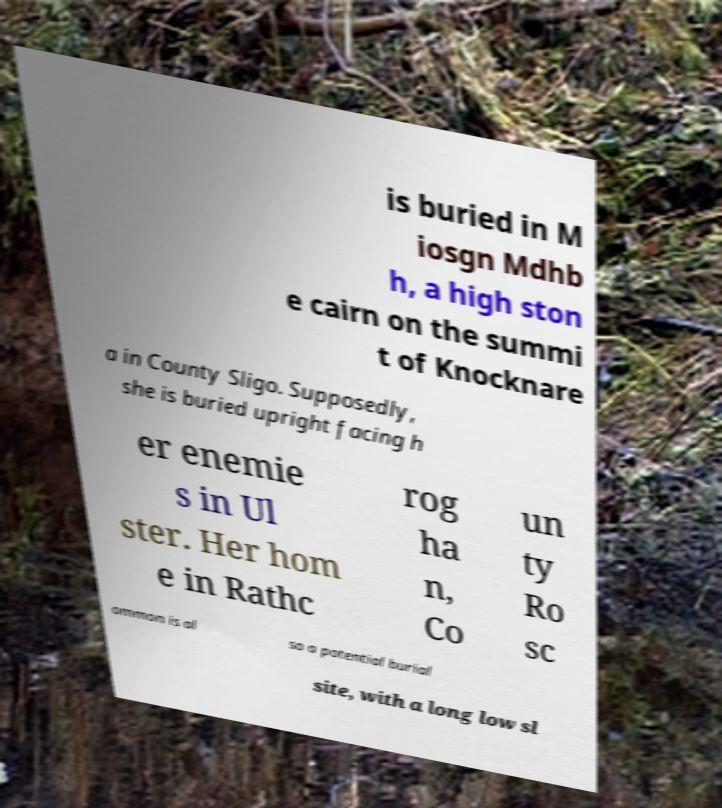What messages or text are displayed in this image? I need them in a readable, typed format. is buried in M iosgn Mdhb h, a high ston e cairn on the summi t of Knocknare a in County Sligo. Supposedly, she is buried upright facing h er enemie s in Ul ster. Her hom e in Rathc rog ha n, Co un ty Ro sc ommon is al so a potential burial site, with a long low sl 